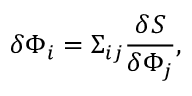<formula> <loc_0><loc_0><loc_500><loc_500>\delta \Phi _ { i } = \Sigma _ { i j } { \frac { \delta S } { \delta \Phi _ { j } } } ,</formula> 